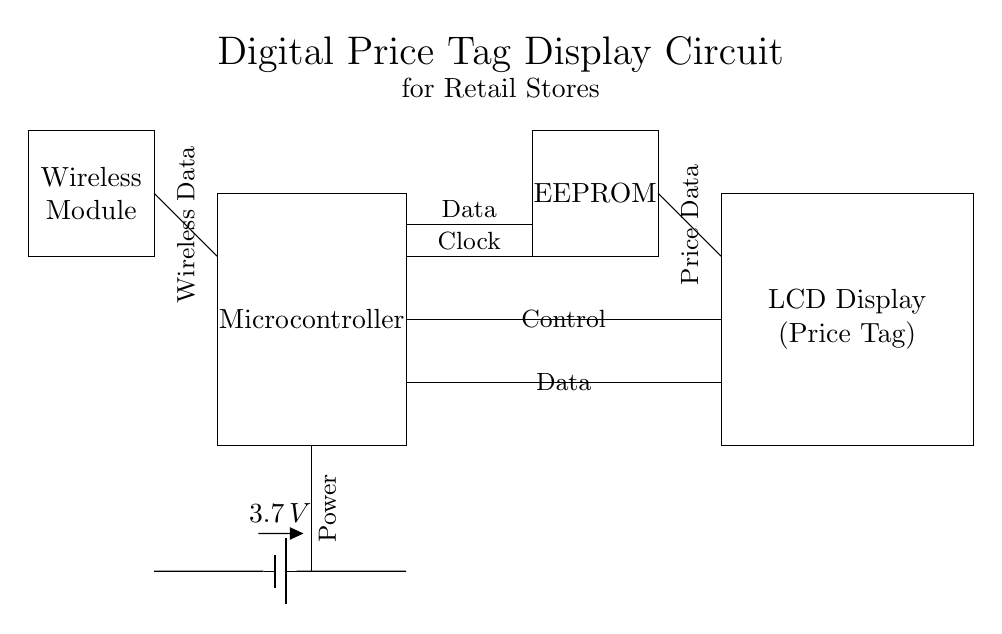What is the main component of the circuit? The main component is the microcontroller, which is responsible for managing the functions of the price tag display.
Answer: Microcontroller What is the voltage of the battery used in the circuit? The voltage specified for the battery component in the circuit is 3.7 volts.
Answer: 3.7 volts What type of data does the EEPROM store? The EEPROM stores data related to control and price data for the display functionality.
Answer: Price data How many main components are there in the circuit? By counting the distinct blocks in the circuit, we find there are four main components: Microcontroller, EEPROM, LCD Display, and Wireless Module.
Answer: Four What is the purpose of the wireless module? The wireless module is used for transmitting and receiving wireless data related to pricing updates and other control signals.
Answer: Transmitting data What type of display is used in the circuit? The display is labeled as an LCD display, which is used to visually show price tags.
Answer: LCD Display Which component connects directly to the battery? The microcontroller connects directly to the battery to receive power and operate the circuit.
Answer: Microcontroller 